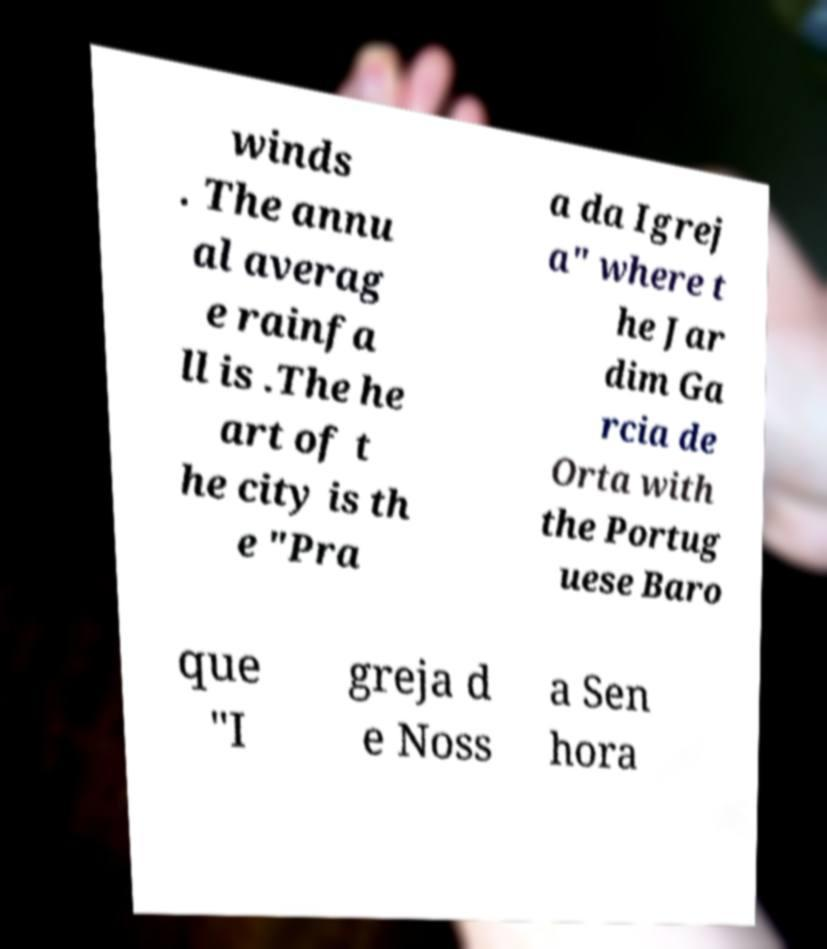Please identify and transcribe the text found in this image. winds . The annu al averag e rainfa ll is .The he art of t he city is th e "Pra a da Igrej a" where t he Jar dim Ga rcia de Orta with the Portug uese Baro que "I greja d e Noss a Sen hora 